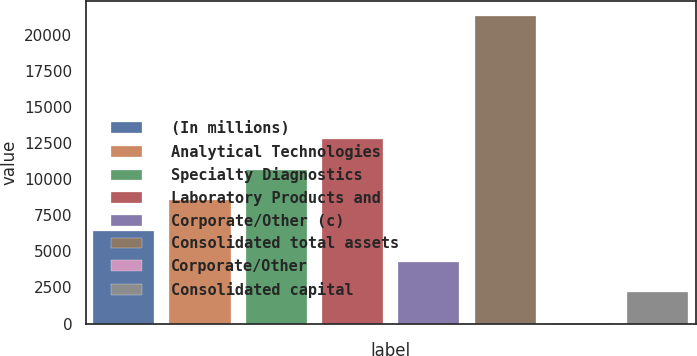Convert chart. <chart><loc_0><loc_0><loc_500><loc_500><bar_chart><fcel>(In millions)<fcel>Analytical Technologies<fcel>Specialty Diagnostics<fcel>Laboratory Products and<fcel>Corporate/Other (c)<fcel>Consolidated total assets<fcel>Corporate/Other<fcel>Consolidated capital<nl><fcel>6422.6<fcel>8555<fcel>10687.4<fcel>12819.8<fcel>4290.2<fcel>21349.4<fcel>25.4<fcel>2157.8<nl></chart> 